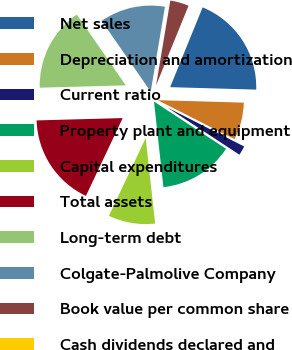<chart> <loc_0><loc_0><loc_500><loc_500><pie_chart><fcel>Net sales<fcel>Depreciation and amortization<fcel>Current ratio<fcel>Property plant and equipment<fcel>Capital expenditures<fcel>Total assets<fcel>Long-term debt<fcel>Colgate-Palmolive Company<fcel>Book value per common share<fcel>Cash dividends declared and<nl><fcel>19.3%<fcel>7.02%<fcel>1.75%<fcel>14.03%<fcel>8.77%<fcel>17.54%<fcel>15.79%<fcel>12.28%<fcel>3.51%<fcel>0.0%<nl></chart> 